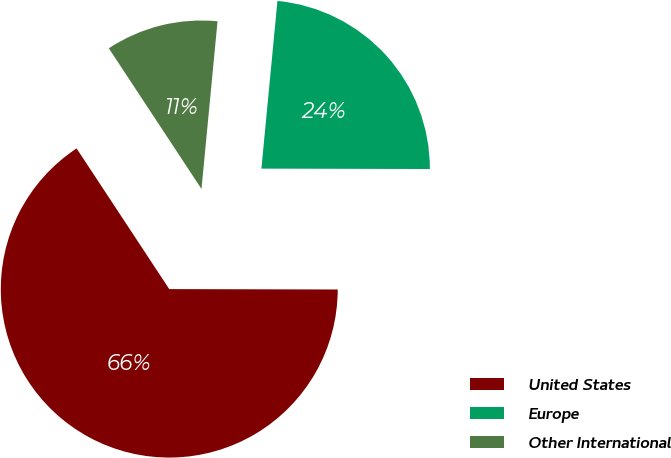Convert chart to OTSL. <chart><loc_0><loc_0><loc_500><loc_500><pie_chart><fcel>United States<fcel>Europe<fcel>Other International<nl><fcel>65.7%<fcel>23.52%<fcel>10.79%<nl></chart> 